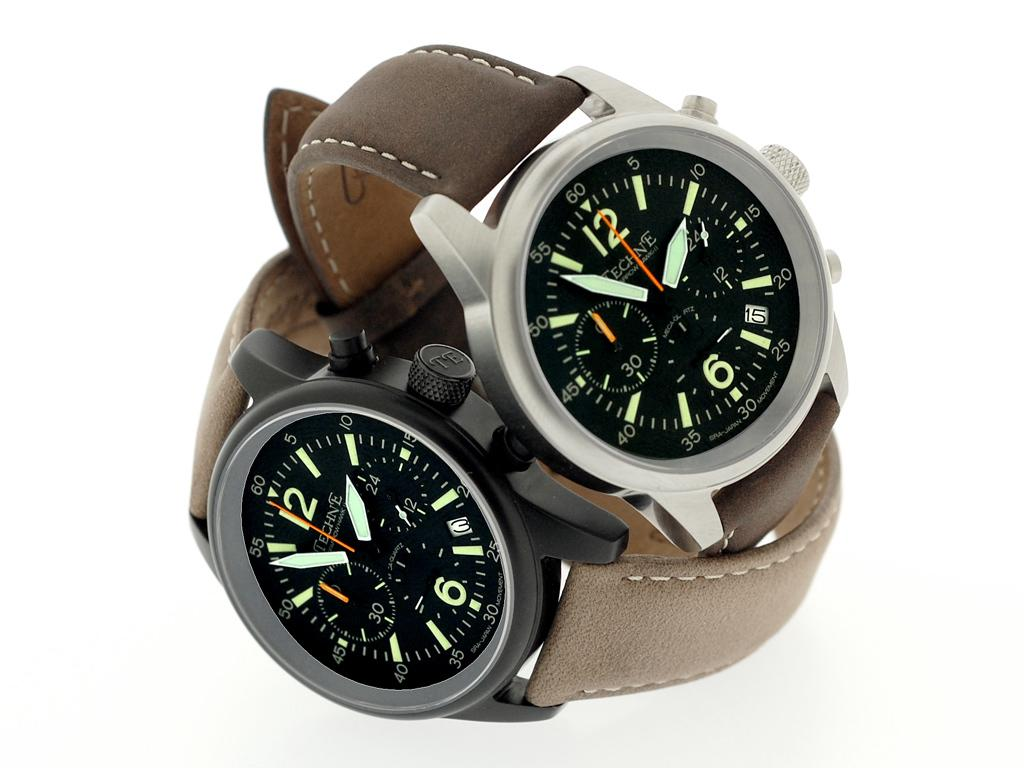<image>
Create a compact narrative representing the image presented. "Techne" is on the faces of two watches. 